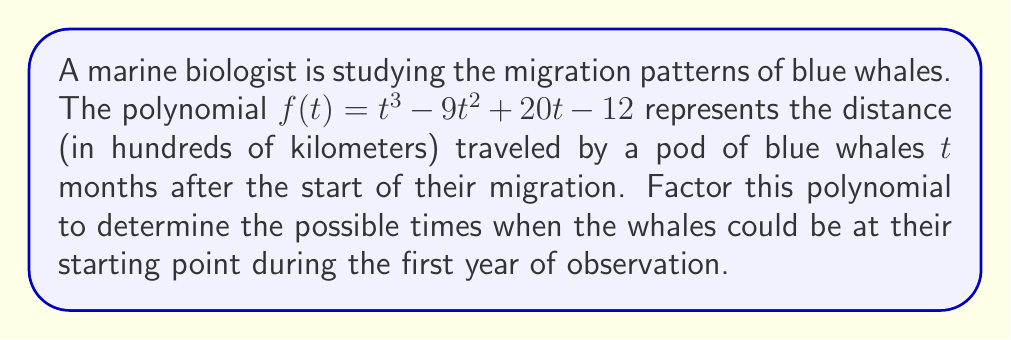Could you help me with this problem? To solve this problem, we need to factor the polynomial $f(t) = t^3 - 9t^2 + 20t - 12$. The whales will be at their starting point when $f(t) = 0$, so we need to find the roots of this polynomial.

Step 1: Check for a common factor
There is no common factor for all terms, so we proceed to the next step.

Step 2: Check if it's a perfect cube
This polynomial is not a perfect cube, so we move on.

Step 3: Try to factor by grouping
Rewrite the polynomial as: $t^3 - 9t^2 + 20t - 12$
Group the terms: $(t^3 - 9t^2) + (20t - 12)$
Factor out common factors from each group:
$t^2(t - 9) + 4(5t - 3)$

We can't factor further by grouping, so we try another method.

Step 4: Guess one root
Since the polynomial has integer coefficients, if it has any rational roots, they must be factors of the constant term, 12. The possible factors are: ±1, ±2, ±3, ±4, ±6, ±12.

Testing these values, we find that $f(1) = 0$, so $(t - 1)$ is a factor.

Step 5: Use polynomial long division
Divide $f(t)$ by $(t - 1)$:

$$\frac{t^3 - 9t^2 + 20t - 12}{t - 1} = t^2 - 8t + 12$$

Step 6: Factor the quadratic remainder
$t^2 - 8t + 12$ can be factored as $(t - 6)(t - 2)$

Therefore, the complete factorization is:

$f(t) = (t - 1)(t - 2)(t - 6)$

The roots of the polynomial are $t = 1$, $t = 2$, and $t = 6$, representing the times (in months) when the whales could be at their starting point during the first year.
Answer: $f(t) = (t - 1)(t - 2)(t - 6)$
The whales could be at their starting point after 1 month, 2 months, and 6 months. 